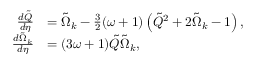<formula> <loc_0><loc_0><loc_500><loc_500>\begin{array} { r l } { \frac { d { \tilde { Q } } } { d \eta } } & { = \tilde { \Omega } _ { k } - \frac { 3 } { 2 } ( \omega + 1 ) \left ( { \tilde { Q } } ^ { 2 } + 2 \tilde { \Omega } _ { k } - 1 \right ) , } \\ { \frac { d { \tilde { \Omega } _ { k } } } { d \eta } } & { = ( 3 \omega + 1 ) { \tilde { Q } } \tilde { \Omega } _ { k } , } \end{array}</formula> 